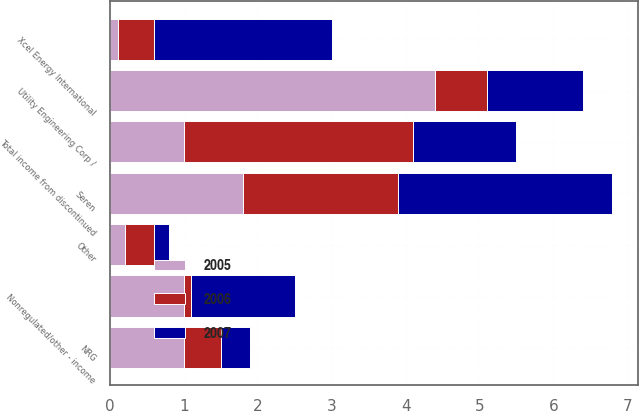<chart> <loc_0><loc_0><loc_500><loc_500><stacked_bar_chart><ecel><fcel>NRG<fcel>Xcel Energy International<fcel>Seren<fcel>Utility Engineering Corp /<fcel>Other<fcel>Nonregulated/other - income<fcel>Total income from discontinued<nl><fcel>2007<fcel>0.4<fcel>2.4<fcel>2.9<fcel>1.3<fcel>0.2<fcel>1.4<fcel>1.4<nl><fcel>2006<fcel>0.5<fcel>0.5<fcel>2.1<fcel>0.7<fcel>0.4<fcel>0.1<fcel>3.1<nl><fcel>2005<fcel>1<fcel>0.1<fcel>1.8<fcel>4.4<fcel>0.2<fcel>1<fcel>1<nl></chart> 